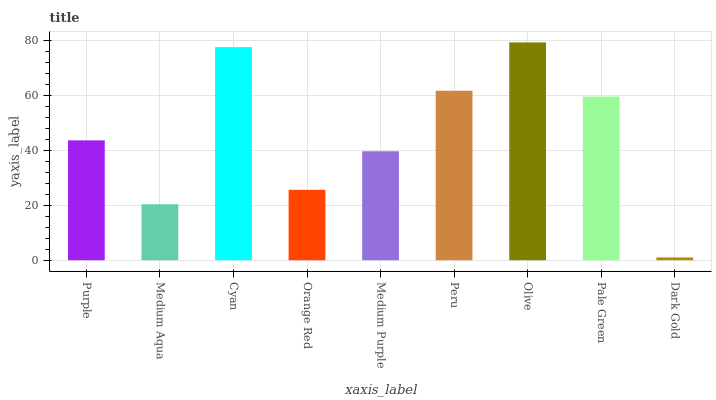Is Medium Aqua the minimum?
Answer yes or no. No. Is Medium Aqua the maximum?
Answer yes or no. No. Is Purple greater than Medium Aqua?
Answer yes or no. Yes. Is Medium Aqua less than Purple?
Answer yes or no. Yes. Is Medium Aqua greater than Purple?
Answer yes or no. No. Is Purple less than Medium Aqua?
Answer yes or no. No. Is Purple the high median?
Answer yes or no. Yes. Is Purple the low median?
Answer yes or no. Yes. Is Medium Aqua the high median?
Answer yes or no. No. Is Medium Purple the low median?
Answer yes or no. No. 